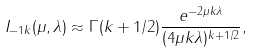<formula> <loc_0><loc_0><loc_500><loc_500>I _ { - 1 k } ( \mu , \lambda ) \approx \Gamma ( k + 1 / 2 ) \frac { e ^ { - 2 \mu k \lambda } } { ( 4 \mu k \lambda ) ^ { k + 1 / 2 } } ,</formula> 